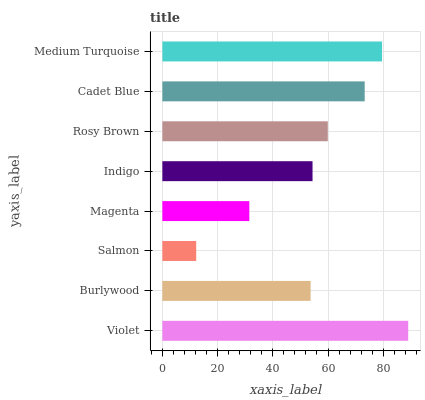Is Salmon the minimum?
Answer yes or no. Yes. Is Violet the maximum?
Answer yes or no. Yes. Is Burlywood the minimum?
Answer yes or no. No. Is Burlywood the maximum?
Answer yes or no. No. Is Violet greater than Burlywood?
Answer yes or no. Yes. Is Burlywood less than Violet?
Answer yes or no. Yes. Is Burlywood greater than Violet?
Answer yes or no. No. Is Violet less than Burlywood?
Answer yes or no. No. Is Rosy Brown the high median?
Answer yes or no. Yes. Is Indigo the low median?
Answer yes or no. Yes. Is Magenta the high median?
Answer yes or no. No. Is Cadet Blue the low median?
Answer yes or no. No. 